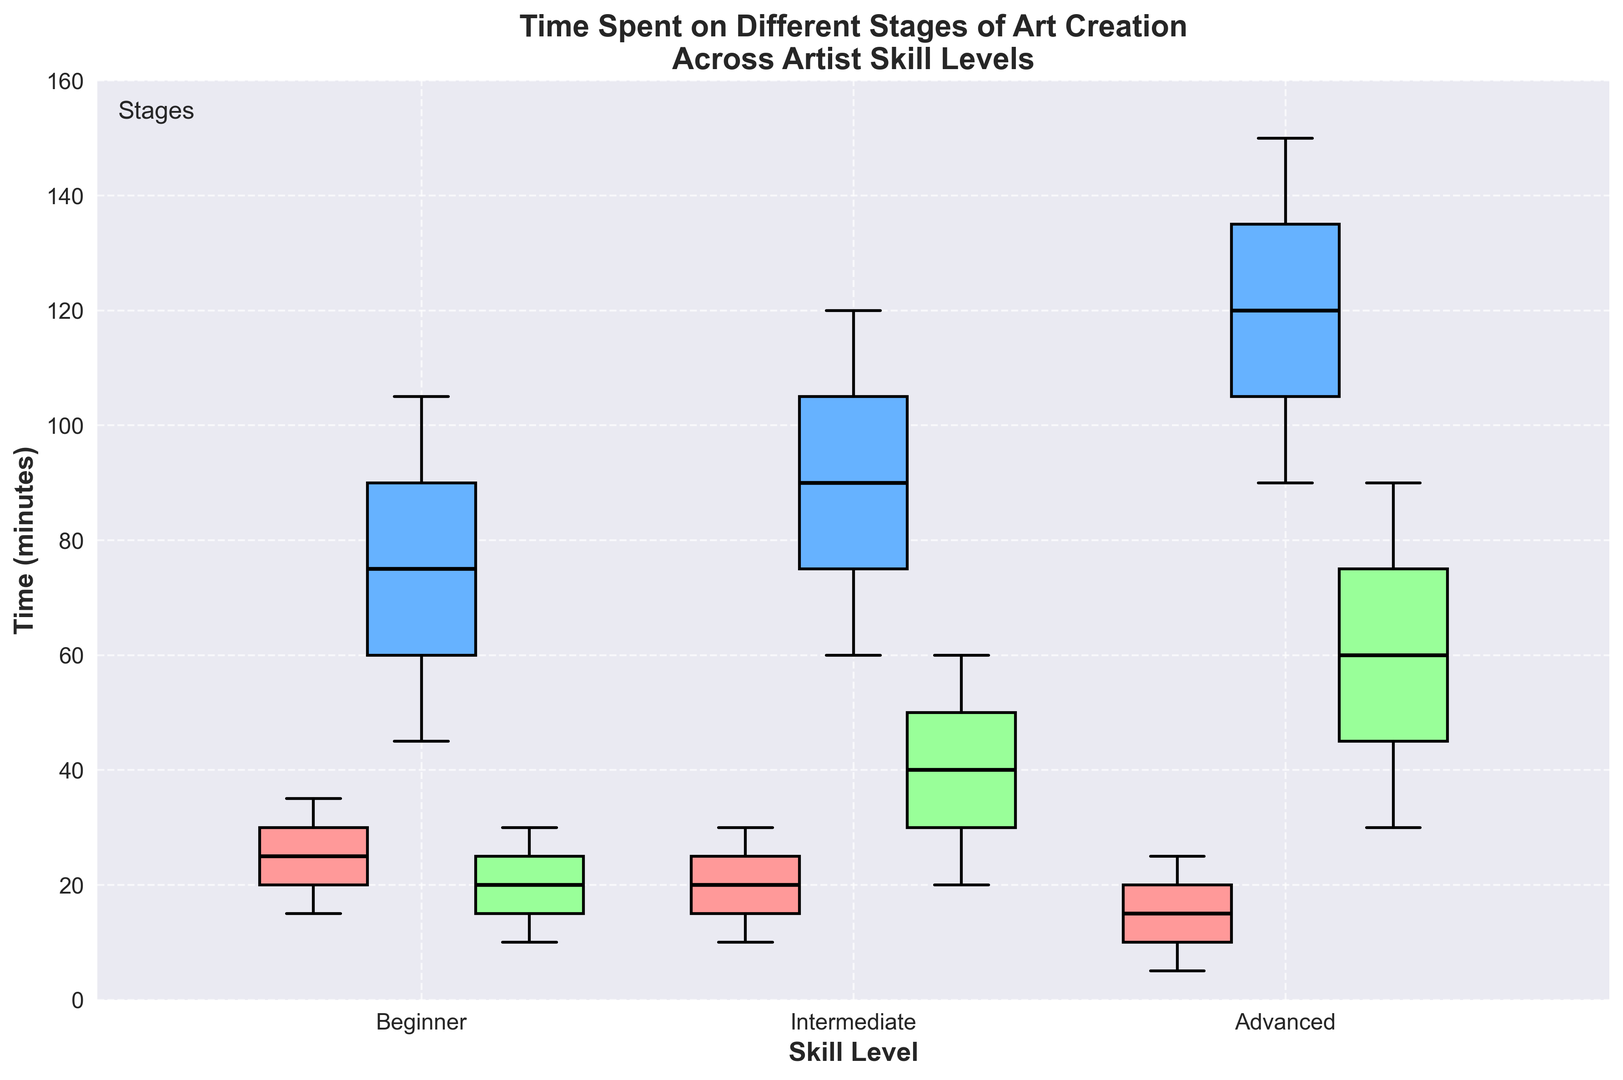What's the median time spent on sketching for Advanced artists? The median is the middle value when data points are arranged in order. For Advanced artists, the sketching times are 5, 10, 15, 20, and 25 minutes. The median value here is 15 minutes.
Answer: 15 Between which skill levels is the time spent on coloring most similar? Compare the median values of the coloring stage for all skill levels. The medians for Beginners, Intermediates, and Advanced artists are 75, 90, and 120 minutes, respectively. Beginners and Intermediate's medians (75 and 90) are closest.
Answer: Beginner and Intermediate What's the range of time spent on refining for Intermediate artists? The range is the difference between the maximum and minimum values. For Intermediate artists, the times are 20, 30, 40, 50, and 60 minutes. The range is 60 - 20 = 40 minutes.
Answer: 40 Which skill level spends the least amount of time on sketching on average? Calculate the average time spent on sketching for each skill level. Beginners: (15+20+25+30+35)/5=25 mins, Intermediate: (10+15+20+25+30)/5=20 mins, Advanced: (5+10+15+20+25)/5=15 mins. Advanced artists spend the least time.
Answer: Advanced How does the median time spent on coloring by Intermediate artists compare to that by Advanced artists? The median time spent on coloring by Intermediate artists is 90 minutes, and for Advanced artists, it's 120 minutes. 90 is less than 120.
Answer: Less than What is the interquartile range (IQR) of refining time for Advanced artists? The IQR is the difference between the third quartile (75th percentile) and the first quartile (25th percentile). For Advanced Refining, values are 30, 45, 60, 75, and 90. Q1 is 45, and Q3 is 75. So, IQR = 75 - 45 = 30.
Answer: 30 Which stage shows the greatest variability in time spent for Beginner artists? Compare the range of times for sketching (35-15=20), coloring (105-45=60), and refining (30-10=20) for Beginners. Coloring has the greatest range (60).
Answer: Coloring Which stage do Advanced artists spend the most time on, on average? Calculate the average time spent for each stage by Advanced artists: Sketching (5+10+15+20+25)/5=15 mins, Coloring (90+105+120+135+150)/5=120 mins, Refining (30+45+60+75+90)/5=60 mins. Advanced artists spend the most time on Coloring.
Answer: Coloring 